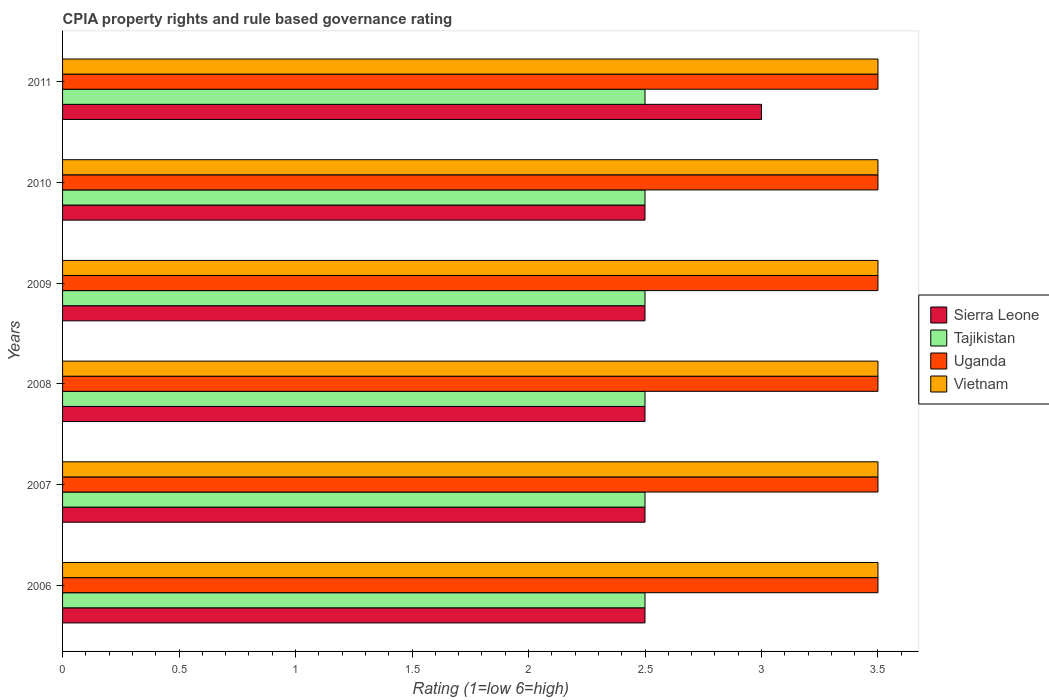Are the number of bars on each tick of the Y-axis equal?
Give a very brief answer. Yes. How many bars are there on the 3rd tick from the top?
Give a very brief answer. 4. What is the label of the 3rd group of bars from the top?
Provide a succinct answer. 2009. What is the CPIA rating in Vietnam in 2006?
Offer a terse response. 3.5. Across all years, what is the maximum CPIA rating in Tajikistan?
Your response must be concise. 2.5. Across all years, what is the minimum CPIA rating in Uganda?
Make the answer very short. 3.5. In which year was the CPIA rating in Tajikistan maximum?
Make the answer very short. 2006. In which year was the CPIA rating in Uganda minimum?
Make the answer very short. 2006. Is the CPIA rating in Tajikistan in 2009 less than that in 2011?
Make the answer very short. No. What is the difference between the highest and the second highest CPIA rating in Uganda?
Give a very brief answer. 0. Is the sum of the CPIA rating in Tajikistan in 2010 and 2011 greater than the maximum CPIA rating in Uganda across all years?
Your answer should be very brief. Yes. What does the 4th bar from the top in 2007 represents?
Your answer should be very brief. Sierra Leone. What does the 1st bar from the bottom in 2009 represents?
Provide a short and direct response. Sierra Leone. Are all the bars in the graph horizontal?
Give a very brief answer. Yes. How many years are there in the graph?
Provide a short and direct response. 6. What is the difference between two consecutive major ticks on the X-axis?
Give a very brief answer. 0.5. Are the values on the major ticks of X-axis written in scientific E-notation?
Provide a short and direct response. No. Where does the legend appear in the graph?
Keep it short and to the point. Center right. How many legend labels are there?
Provide a short and direct response. 4. How are the legend labels stacked?
Provide a short and direct response. Vertical. What is the title of the graph?
Ensure brevity in your answer.  CPIA property rights and rule based governance rating. Does "East Asia (developing only)" appear as one of the legend labels in the graph?
Provide a short and direct response. No. What is the Rating (1=low 6=high) in Uganda in 2006?
Offer a terse response. 3.5. What is the Rating (1=low 6=high) in Vietnam in 2006?
Offer a terse response. 3.5. What is the Rating (1=low 6=high) of Sierra Leone in 2007?
Your answer should be very brief. 2.5. What is the Rating (1=low 6=high) of Tajikistan in 2007?
Make the answer very short. 2.5. What is the Rating (1=low 6=high) in Sierra Leone in 2008?
Your response must be concise. 2.5. What is the Rating (1=low 6=high) of Tajikistan in 2008?
Ensure brevity in your answer.  2.5. What is the Rating (1=low 6=high) in Uganda in 2008?
Give a very brief answer. 3.5. What is the Rating (1=low 6=high) of Vietnam in 2008?
Your response must be concise. 3.5. What is the Rating (1=low 6=high) in Uganda in 2009?
Make the answer very short. 3.5. What is the Rating (1=low 6=high) in Vietnam in 2009?
Offer a very short reply. 3.5. What is the Rating (1=low 6=high) in Sierra Leone in 2010?
Offer a very short reply. 2.5. What is the Rating (1=low 6=high) of Tajikistan in 2010?
Your answer should be compact. 2.5. What is the Rating (1=low 6=high) of Uganda in 2011?
Offer a very short reply. 3.5. What is the Rating (1=low 6=high) of Vietnam in 2011?
Provide a succinct answer. 3.5. Across all years, what is the maximum Rating (1=low 6=high) in Sierra Leone?
Give a very brief answer. 3. Across all years, what is the maximum Rating (1=low 6=high) of Tajikistan?
Provide a succinct answer. 2.5. Across all years, what is the maximum Rating (1=low 6=high) in Uganda?
Your answer should be very brief. 3.5. Across all years, what is the maximum Rating (1=low 6=high) in Vietnam?
Offer a very short reply. 3.5. Across all years, what is the minimum Rating (1=low 6=high) of Vietnam?
Provide a succinct answer. 3.5. What is the total Rating (1=low 6=high) of Sierra Leone in the graph?
Your answer should be very brief. 15.5. What is the total Rating (1=low 6=high) of Uganda in the graph?
Provide a succinct answer. 21. What is the difference between the Rating (1=low 6=high) of Tajikistan in 2006 and that in 2007?
Make the answer very short. 0. What is the difference between the Rating (1=low 6=high) of Uganda in 2006 and that in 2007?
Offer a terse response. 0. What is the difference between the Rating (1=low 6=high) of Vietnam in 2006 and that in 2007?
Ensure brevity in your answer.  0. What is the difference between the Rating (1=low 6=high) of Tajikistan in 2006 and that in 2008?
Ensure brevity in your answer.  0. What is the difference between the Rating (1=low 6=high) of Vietnam in 2006 and that in 2008?
Make the answer very short. 0. What is the difference between the Rating (1=low 6=high) in Sierra Leone in 2006 and that in 2009?
Keep it short and to the point. 0. What is the difference between the Rating (1=low 6=high) of Sierra Leone in 2006 and that in 2010?
Your answer should be compact. 0. What is the difference between the Rating (1=low 6=high) of Tajikistan in 2006 and that in 2010?
Your response must be concise. 0. What is the difference between the Rating (1=low 6=high) in Uganda in 2006 and that in 2010?
Offer a terse response. 0. What is the difference between the Rating (1=low 6=high) in Sierra Leone in 2006 and that in 2011?
Your answer should be compact. -0.5. What is the difference between the Rating (1=low 6=high) of Tajikistan in 2006 and that in 2011?
Your response must be concise. 0. What is the difference between the Rating (1=low 6=high) in Uganda in 2006 and that in 2011?
Ensure brevity in your answer.  0. What is the difference between the Rating (1=low 6=high) of Sierra Leone in 2007 and that in 2008?
Your answer should be very brief. 0. What is the difference between the Rating (1=low 6=high) of Tajikistan in 2007 and that in 2008?
Your answer should be compact. 0. What is the difference between the Rating (1=low 6=high) in Vietnam in 2007 and that in 2008?
Your answer should be compact. 0. What is the difference between the Rating (1=low 6=high) of Sierra Leone in 2007 and that in 2009?
Make the answer very short. 0. What is the difference between the Rating (1=low 6=high) of Sierra Leone in 2007 and that in 2010?
Make the answer very short. 0. What is the difference between the Rating (1=low 6=high) in Vietnam in 2007 and that in 2010?
Offer a very short reply. 0. What is the difference between the Rating (1=low 6=high) in Vietnam in 2007 and that in 2011?
Keep it short and to the point. 0. What is the difference between the Rating (1=low 6=high) in Vietnam in 2008 and that in 2009?
Keep it short and to the point. 0. What is the difference between the Rating (1=low 6=high) of Tajikistan in 2008 and that in 2010?
Provide a short and direct response. 0. What is the difference between the Rating (1=low 6=high) of Sierra Leone in 2008 and that in 2011?
Your answer should be very brief. -0.5. What is the difference between the Rating (1=low 6=high) of Tajikistan in 2009 and that in 2011?
Make the answer very short. 0. What is the difference between the Rating (1=low 6=high) in Sierra Leone in 2006 and the Rating (1=low 6=high) in Tajikistan in 2007?
Offer a terse response. 0. What is the difference between the Rating (1=low 6=high) of Sierra Leone in 2006 and the Rating (1=low 6=high) of Uganda in 2007?
Ensure brevity in your answer.  -1. What is the difference between the Rating (1=low 6=high) in Sierra Leone in 2006 and the Rating (1=low 6=high) in Tajikistan in 2008?
Your answer should be very brief. 0. What is the difference between the Rating (1=low 6=high) in Sierra Leone in 2006 and the Rating (1=low 6=high) in Uganda in 2008?
Provide a short and direct response. -1. What is the difference between the Rating (1=low 6=high) of Uganda in 2006 and the Rating (1=low 6=high) of Vietnam in 2008?
Your answer should be very brief. 0. What is the difference between the Rating (1=low 6=high) in Sierra Leone in 2006 and the Rating (1=low 6=high) in Tajikistan in 2009?
Offer a very short reply. 0. What is the difference between the Rating (1=low 6=high) in Sierra Leone in 2006 and the Rating (1=low 6=high) in Uganda in 2009?
Keep it short and to the point. -1. What is the difference between the Rating (1=low 6=high) in Sierra Leone in 2006 and the Rating (1=low 6=high) in Vietnam in 2009?
Provide a succinct answer. -1. What is the difference between the Rating (1=low 6=high) in Sierra Leone in 2006 and the Rating (1=low 6=high) in Tajikistan in 2010?
Your answer should be very brief. 0. What is the difference between the Rating (1=low 6=high) in Sierra Leone in 2006 and the Rating (1=low 6=high) in Uganda in 2010?
Give a very brief answer. -1. What is the difference between the Rating (1=low 6=high) of Tajikistan in 2006 and the Rating (1=low 6=high) of Uganda in 2010?
Give a very brief answer. -1. What is the difference between the Rating (1=low 6=high) in Tajikistan in 2006 and the Rating (1=low 6=high) in Vietnam in 2010?
Give a very brief answer. -1. What is the difference between the Rating (1=low 6=high) of Sierra Leone in 2006 and the Rating (1=low 6=high) of Tajikistan in 2011?
Your response must be concise. 0. What is the difference between the Rating (1=low 6=high) of Uganda in 2006 and the Rating (1=low 6=high) of Vietnam in 2011?
Your answer should be very brief. 0. What is the difference between the Rating (1=low 6=high) of Sierra Leone in 2007 and the Rating (1=low 6=high) of Tajikistan in 2008?
Offer a very short reply. 0. What is the difference between the Rating (1=low 6=high) in Sierra Leone in 2007 and the Rating (1=low 6=high) in Vietnam in 2008?
Keep it short and to the point. -1. What is the difference between the Rating (1=low 6=high) in Uganda in 2007 and the Rating (1=low 6=high) in Vietnam in 2008?
Ensure brevity in your answer.  0. What is the difference between the Rating (1=low 6=high) in Sierra Leone in 2007 and the Rating (1=low 6=high) in Tajikistan in 2009?
Provide a succinct answer. 0. What is the difference between the Rating (1=low 6=high) of Sierra Leone in 2007 and the Rating (1=low 6=high) of Uganda in 2009?
Your response must be concise. -1. What is the difference between the Rating (1=low 6=high) of Tajikistan in 2007 and the Rating (1=low 6=high) of Vietnam in 2009?
Your response must be concise. -1. What is the difference between the Rating (1=low 6=high) of Uganda in 2007 and the Rating (1=low 6=high) of Vietnam in 2009?
Provide a short and direct response. 0. What is the difference between the Rating (1=low 6=high) in Sierra Leone in 2007 and the Rating (1=low 6=high) in Tajikistan in 2010?
Your response must be concise. 0. What is the difference between the Rating (1=low 6=high) of Tajikistan in 2007 and the Rating (1=low 6=high) of Vietnam in 2010?
Offer a very short reply. -1. What is the difference between the Rating (1=low 6=high) of Sierra Leone in 2007 and the Rating (1=low 6=high) of Tajikistan in 2011?
Provide a succinct answer. 0. What is the difference between the Rating (1=low 6=high) in Sierra Leone in 2007 and the Rating (1=low 6=high) in Vietnam in 2011?
Offer a very short reply. -1. What is the difference between the Rating (1=low 6=high) of Uganda in 2007 and the Rating (1=low 6=high) of Vietnam in 2011?
Offer a terse response. 0. What is the difference between the Rating (1=low 6=high) in Sierra Leone in 2008 and the Rating (1=low 6=high) in Tajikistan in 2009?
Your answer should be very brief. 0. What is the difference between the Rating (1=low 6=high) in Sierra Leone in 2008 and the Rating (1=low 6=high) in Uganda in 2009?
Provide a succinct answer. -1. What is the difference between the Rating (1=low 6=high) in Sierra Leone in 2008 and the Rating (1=low 6=high) in Tajikistan in 2010?
Provide a succinct answer. 0. What is the difference between the Rating (1=low 6=high) of Tajikistan in 2008 and the Rating (1=low 6=high) of Vietnam in 2010?
Your response must be concise. -1. What is the difference between the Rating (1=low 6=high) of Uganda in 2008 and the Rating (1=low 6=high) of Vietnam in 2010?
Your response must be concise. 0. What is the difference between the Rating (1=low 6=high) in Sierra Leone in 2008 and the Rating (1=low 6=high) in Vietnam in 2011?
Your response must be concise. -1. What is the difference between the Rating (1=low 6=high) of Tajikistan in 2008 and the Rating (1=low 6=high) of Uganda in 2011?
Provide a succinct answer. -1. What is the difference between the Rating (1=low 6=high) in Tajikistan in 2008 and the Rating (1=low 6=high) in Vietnam in 2011?
Offer a terse response. -1. What is the difference between the Rating (1=low 6=high) in Sierra Leone in 2009 and the Rating (1=low 6=high) in Tajikistan in 2010?
Your answer should be compact. 0. What is the difference between the Rating (1=low 6=high) of Sierra Leone in 2009 and the Rating (1=low 6=high) of Uganda in 2010?
Give a very brief answer. -1. What is the difference between the Rating (1=low 6=high) of Tajikistan in 2009 and the Rating (1=low 6=high) of Uganda in 2010?
Provide a short and direct response. -1. What is the difference between the Rating (1=low 6=high) in Sierra Leone in 2009 and the Rating (1=low 6=high) in Uganda in 2011?
Ensure brevity in your answer.  -1. What is the difference between the Rating (1=low 6=high) in Sierra Leone in 2009 and the Rating (1=low 6=high) in Vietnam in 2011?
Your answer should be compact. -1. What is the difference between the Rating (1=low 6=high) in Tajikistan in 2009 and the Rating (1=low 6=high) in Vietnam in 2011?
Make the answer very short. -1. What is the difference between the Rating (1=low 6=high) of Uganda in 2009 and the Rating (1=low 6=high) of Vietnam in 2011?
Your answer should be very brief. 0. What is the difference between the Rating (1=low 6=high) in Sierra Leone in 2010 and the Rating (1=low 6=high) in Vietnam in 2011?
Offer a terse response. -1. What is the average Rating (1=low 6=high) in Sierra Leone per year?
Offer a terse response. 2.58. What is the average Rating (1=low 6=high) of Uganda per year?
Offer a terse response. 3.5. What is the average Rating (1=low 6=high) in Vietnam per year?
Give a very brief answer. 3.5. In the year 2006, what is the difference between the Rating (1=low 6=high) of Sierra Leone and Rating (1=low 6=high) of Tajikistan?
Your answer should be compact. 0. In the year 2006, what is the difference between the Rating (1=low 6=high) in Sierra Leone and Rating (1=low 6=high) in Uganda?
Ensure brevity in your answer.  -1. In the year 2006, what is the difference between the Rating (1=low 6=high) of Sierra Leone and Rating (1=low 6=high) of Vietnam?
Make the answer very short. -1. In the year 2006, what is the difference between the Rating (1=low 6=high) of Tajikistan and Rating (1=low 6=high) of Vietnam?
Your answer should be compact. -1. In the year 2006, what is the difference between the Rating (1=low 6=high) of Uganda and Rating (1=low 6=high) of Vietnam?
Your response must be concise. 0. In the year 2007, what is the difference between the Rating (1=low 6=high) of Sierra Leone and Rating (1=low 6=high) of Uganda?
Your answer should be compact. -1. In the year 2007, what is the difference between the Rating (1=low 6=high) in Tajikistan and Rating (1=low 6=high) in Uganda?
Give a very brief answer. -1. In the year 2007, what is the difference between the Rating (1=low 6=high) in Uganda and Rating (1=low 6=high) in Vietnam?
Offer a very short reply. 0. In the year 2008, what is the difference between the Rating (1=low 6=high) of Sierra Leone and Rating (1=low 6=high) of Uganda?
Keep it short and to the point. -1. In the year 2008, what is the difference between the Rating (1=low 6=high) in Sierra Leone and Rating (1=low 6=high) in Vietnam?
Offer a terse response. -1. In the year 2008, what is the difference between the Rating (1=low 6=high) of Tajikistan and Rating (1=low 6=high) of Uganda?
Your answer should be compact. -1. In the year 2009, what is the difference between the Rating (1=low 6=high) in Sierra Leone and Rating (1=low 6=high) in Vietnam?
Give a very brief answer. -1. In the year 2009, what is the difference between the Rating (1=low 6=high) of Tajikistan and Rating (1=low 6=high) of Vietnam?
Offer a very short reply. -1. In the year 2010, what is the difference between the Rating (1=low 6=high) of Sierra Leone and Rating (1=low 6=high) of Tajikistan?
Make the answer very short. 0. In the year 2010, what is the difference between the Rating (1=low 6=high) in Sierra Leone and Rating (1=low 6=high) in Uganda?
Your response must be concise. -1. In the year 2010, what is the difference between the Rating (1=low 6=high) in Sierra Leone and Rating (1=low 6=high) in Vietnam?
Your response must be concise. -1. In the year 2010, what is the difference between the Rating (1=low 6=high) in Tajikistan and Rating (1=low 6=high) in Uganda?
Offer a very short reply. -1. In the year 2010, what is the difference between the Rating (1=low 6=high) of Tajikistan and Rating (1=low 6=high) of Vietnam?
Your answer should be very brief. -1. In the year 2010, what is the difference between the Rating (1=low 6=high) of Uganda and Rating (1=low 6=high) of Vietnam?
Make the answer very short. 0. In the year 2011, what is the difference between the Rating (1=low 6=high) of Sierra Leone and Rating (1=low 6=high) of Tajikistan?
Offer a very short reply. 0.5. In the year 2011, what is the difference between the Rating (1=low 6=high) in Tajikistan and Rating (1=low 6=high) in Vietnam?
Provide a succinct answer. -1. What is the ratio of the Rating (1=low 6=high) of Tajikistan in 2006 to that in 2007?
Provide a short and direct response. 1. What is the ratio of the Rating (1=low 6=high) in Sierra Leone in 2006 to that in 2008?
Offer a terse response. 1. What is the ratio of the Rating (1=low 6=high) of Uganda in 2006 to that in 2008?
Offer a terse response. 1. What is the ratio of the Rating (1=low 6=high) of Sierra Leone in 2006 to that in 2009?
Keep it short and to the point. 1. What is the ratio of the Rating (1=low 6=high) in Tajikistan in 2006 to that in 2009?
Give a very brief answer. 1. What is the ratio of the Rating (1=low 6=high) of Vietnam in 2006 to that in 2009?
Ensure brevity in your answer.  1. What is the ratio of the Rating (1=low 6=high) in Sierra Leone in 2006 to that in 2010?
Provide a succinct answer. 1. What is the ratio of the Rating (1=low 6=high) in Vietnam in 2006 to that in 2010?
Your answer should be very brief. 1. What is the ratio of the Rating (1=low 6=high) of Tajikistan in 2006 to that in 2011?
Ensure brevity in your answer.  1. What is the ratio of the Rating (1=low 6=high) of Uganda in 2006 to that in 2011?
Provide a succinct answer. 1. What is the ratio of the Rating (1=low 6=high) in Vietnam in 2006 to that in 2011?
Your answer should be very brief. 1. What is the ratio of the Rating (1=low 6=high) in Sierra Leone in 2007 to that in 2008?
Keep it short and to the point. 1. What is the ratio of the Rating (1=low 6=high) in Tajikistan in 2007 to that in 2008?
Your response must be concise. 1. What is the ratio of the Rating (1=low 6=high) of Vietnam in 2007 to that in 2008?
Make the answer very short. 1. What is the ratio of the Rating (1=low 6=high) of Sierra Leone in 2007 to that in 2009?
Provide a short and direct response. 1. What is the ratio of the Rating (1=low 6=high) of Uganda in 2007 to that in 2009?
Your answer should be very brief. 1. What is the ratio of the Rating (1=low 6=high) of Tajikistan in 2007 to that in 2010?
Make the answer very short. 1. What is the ratio of the Rating (1=low 6=high) of Uganda in 2007 to that in 2010?
Offer a terse response. 1. What is the ratio of the Rating (1=low 6=high) in Vietnam in 2007 to that in 2010?
Provide a succinct answer. 1. What is the ratio of the Rating (1=low 6=high) of Tajikistan in 2007 to that in 2011?
Offer a terse response. 1. What is the ratio of the Rating (1=low 6=high) of Uganda in 2007 to that in 2011?
Your answer should be compact. 1. What is the ratio of the Rating (1=low 6=high) in Vietnam in 2008 to that in 2009?
Provide a short and direct response. 1. What is the ratio of the Rating (1=low 6=high) in Sierra Leone in 2008 to that in 2010?
Your answer should be very brief. 1. What is the ratio of the Rating (1=low 6=high) of Tajikistan in 2008 to that in 2010?
Ensure brevity in your answer.  1. What is the ratio of the Rating (1=low 6=high) of Vietnam in 2008 to that in 2010?
Make the answer very short. 1. What is the ratio of the Rating (1=low 6=high) of Sierra Leone in 2008 to that in 2011?
Your response must be concise. 0.83. What is the ratio of the Rating (1=low 6=high) in Tajikistan in 2008 to that in 2011?
Provide a short and direct response. 1. What is the ratio of the Rating (1=low 6=high) of Vietnam in 2008 to that in 2011?
Ensure brevity in your answer.  1. What is the ratio of the Rating (1=low 6=high) in Tajikistan in 2009 to that in 2010?
Your response must be concise. 1. What is the ratio of the Rating (1=low 6=high) in Uganda in 2009 to that in 2010?
Keep it short and to the point. 1. What is the ratio of the Rating (1=low 6=high) in Vietnam in 2009 to that in 2010?
Keep it short and to the point. 1. What is the ratio of the Rating (1=low 6=high) in Sierra Leone in 2009 to that in 2011?
Make the answer very short. 0.83. What is the ratio of the Rating (1=low 6=high) in Uganda in 2009 to that in 2011?
Provide a short and direct response. 1. What is the ratio of the Rating (1=low 6=high) in Vietnam in 2010 to that in 2011?
Give a very brief answer. 1. What is the difference between the highest and the second highest Rating (1=low 6=high) of Vietnam?
Your response must be concise. 0. What is the difference between the highest and the lowest Rating (1=low 6=high) of Tajikistan?
Ensure brevity in your answer.  0. What is the difference between the highest and the lowest Rating (1=low 6=high) in Uganda?
Offer a very short reply. 0. 